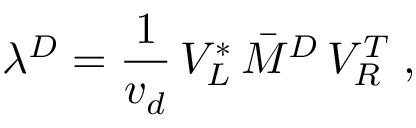Convert formula to latex. <formula><loc_0><loc_0><loc_500><loc_500>\lambda ^ { D } = \frac { 1 } { v _ { d } } \, V _ { L } ^ { * } \, { \bar { M } } ^ { D } \, V _ { R } ^ { T } \, ,</formula> 